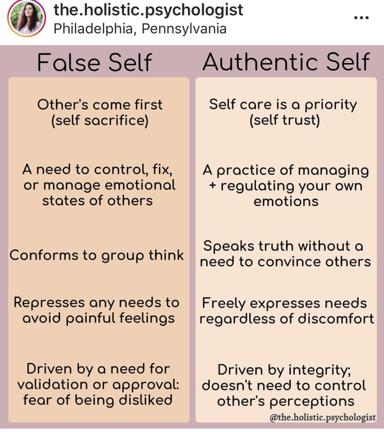What profession does the creator of this content seem to have? The creator of the content in the image is likely a psychologist, specializing in holistic psychology. This field integrates various aspects of psychological health and emphasizes the interconnectedness of mental, physical, and spiritual well-being, aligning perfectly with the dualistic concepts of self depicted in the image. 